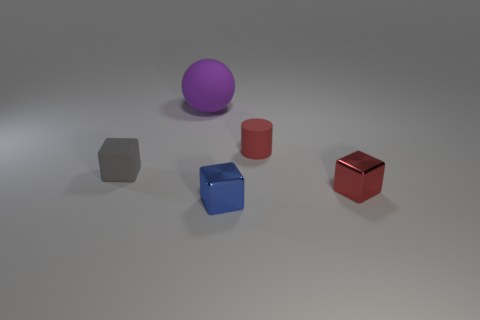Add 5 large gray metal objects. How many objects exist? 10 Subtract all blocks. How many objects are left? 2 Add 3 blue matte cubes. How many blue matte cubes exist? 3 Subtract 0 green cylinders. How many objects are left? 5 Subtract all large yellow things. Subtract all cubes. How many objects are left? 2 Add 2 tiny metal things. How many tiny metal things are left? 4 